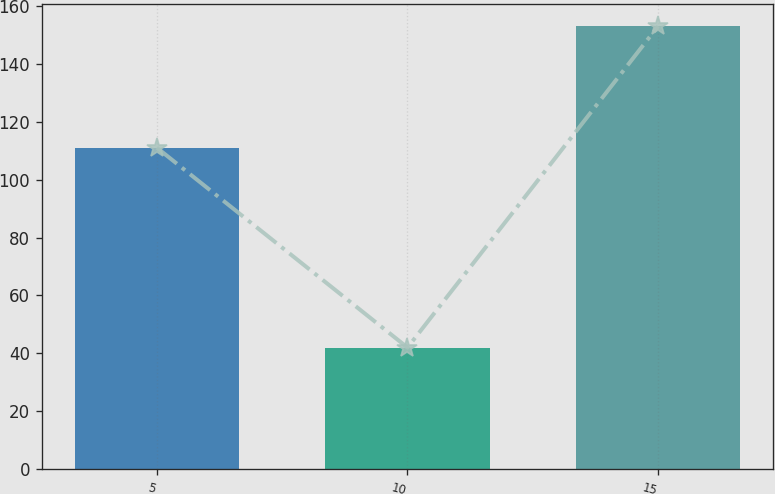<chart> <loc_0><loc_0><loc_500><loc_500><bar_chart><fcel>5<fcel>10<fcel>15<nl><fcel>111<fcel>42<fcel>153<nl></chart> 